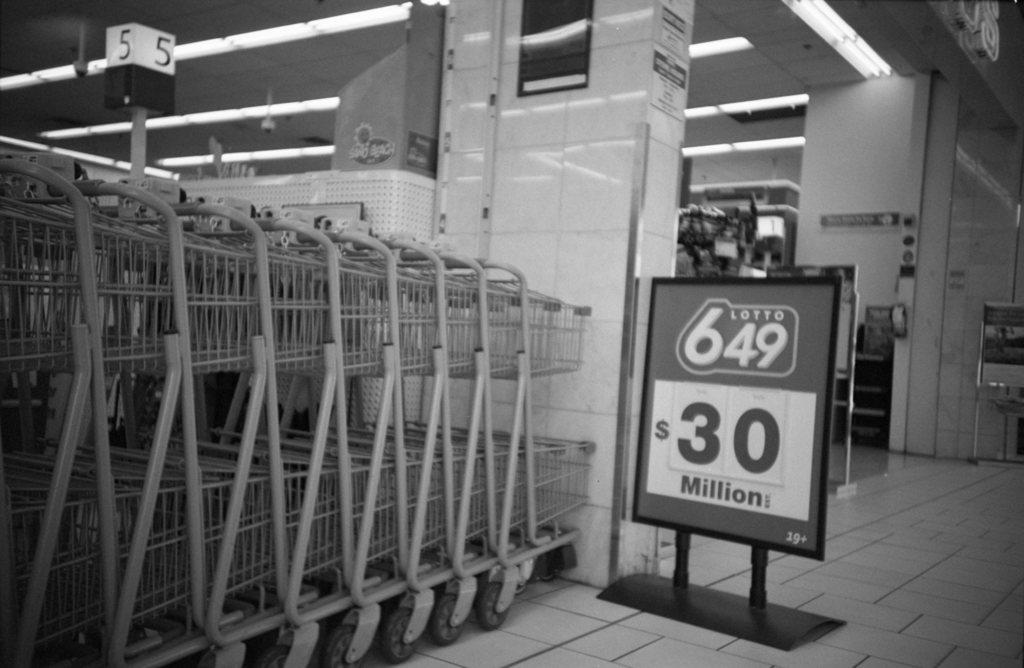Provide a one-sentence caption for the provided image. A series of shopping carts next to a Lotto for 30 million sign. 